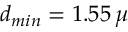Convert formula to latex. <formula><loc_0><loc_0><loc_500><loc_500>d _ { \min } = 1 . 5 5 \, \mu</formula> 